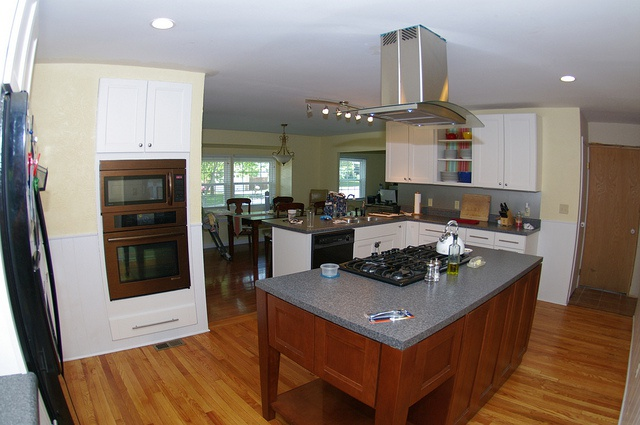Describe the objects in this image and their specific colors. I can see refrigerator in white, black, darkgray, and gray tones, oven in white, black, maroon, and gray tones, microwave in white, black, gray, and maroon tones, dining table in white, black, gray, and maroon tones, and chair in white, black, gray, and darkgreen tones in this image. 